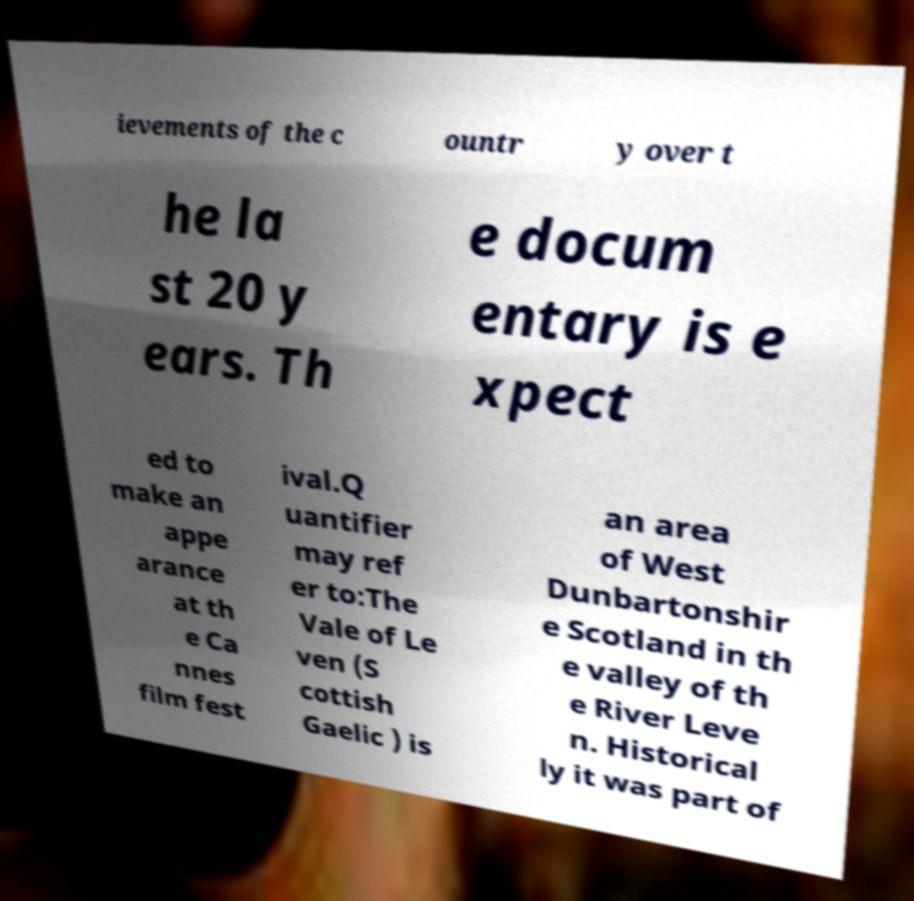Could you assist in decoding the text presented in this image and type it out clearly? ievements of the c ountr y over t he la st 20 y ears. Th e docum entary is e xpect ed to make an appe arance at th e Ca nnes film fest ival.Q uantifier may ref er to:The Vale of Le ven (S cottish Gaelic ) is an area of West Dunbartonshir e Scotland in th e valley of th e River Leve n. Historical ly it was part of 